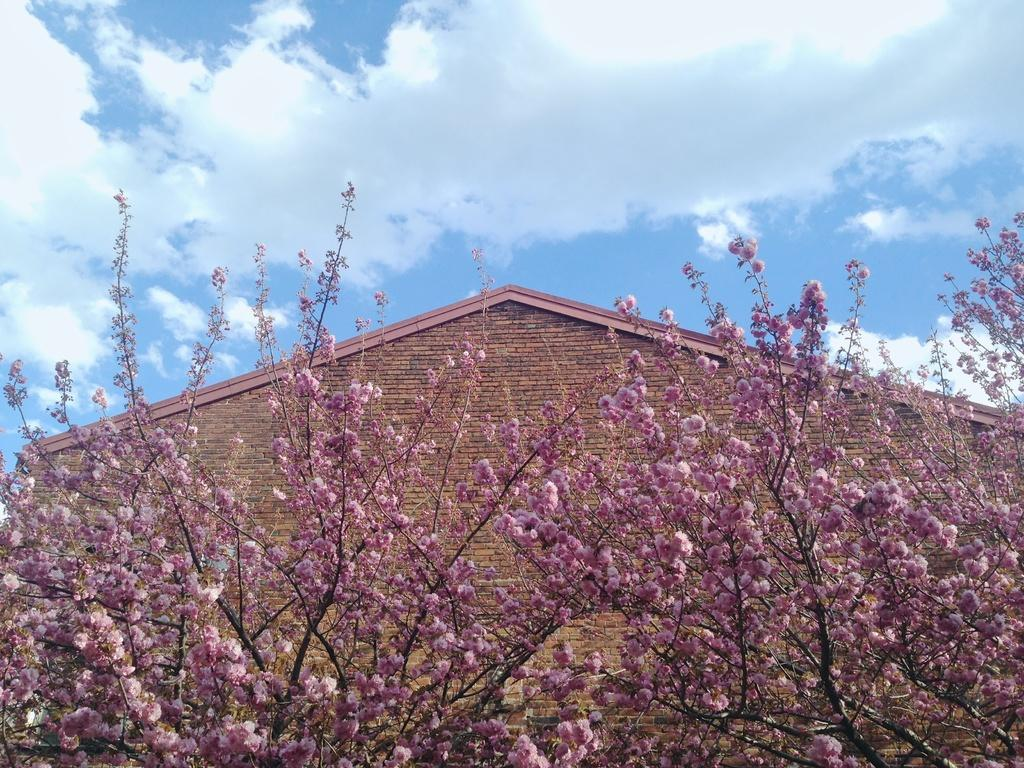What color are the flowers on the trees in the image? The flowers on the trees are pink. What can be seen in the background of the image? There is a building in the background. What is visible above the trees and building in the image? The sky is visible in the image. What can be observed in the sky in the image? Clouds are present in the sky. What type of salt is being used to season the flowers in the image? There is no salt present in the image, and the flowers are not being seasoned. 